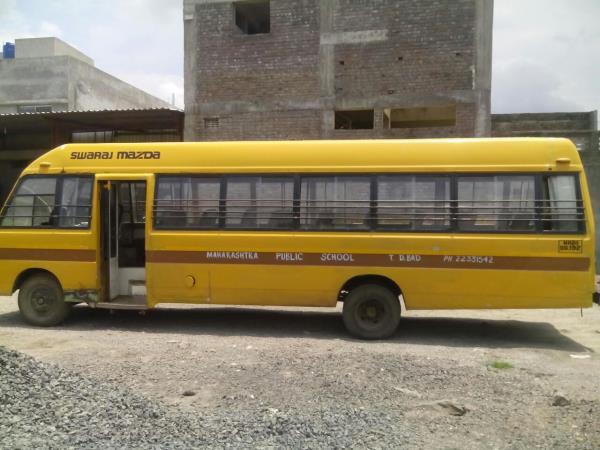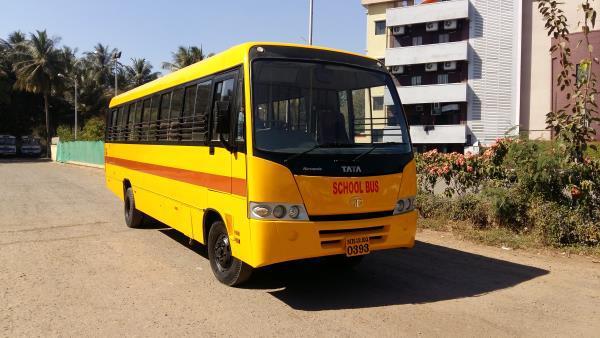The first image is the image on the left, the second image is the image on the right. For the images displayed, is the sentence "Each image shows the front of a flat-fronted bus, and the buses depicted on the left and right are angled in opposite directions." factually correct? Answer yes or no. No. 